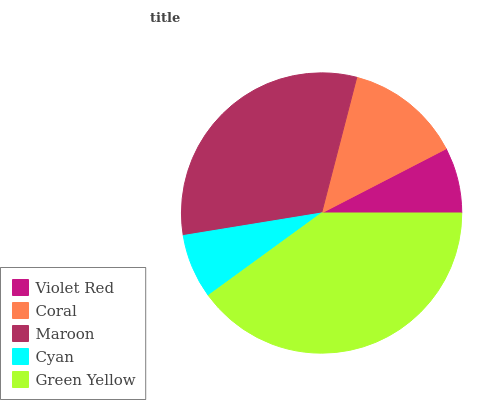Is Cyan the minimum?
Answer yes or no. Yes. Is Green Yellow the maximum?
Answer yes or no. Yes. Is Coral the minimum?
Answer yes or no. No. Is Coral the maximum?
Answer yes or no. No. Is Coral greater than Violet Red?
Answer yes or no. Yes. Is Violet Red less than Coral?
Answer yes or no. Yes. Is Violet Red greater than Coral?
Answer yes or no. No. Is Coral less than Violet Red?
Answer yes or no. No. Is Coral the high median?
Answer yes or no. Yes. Is Coral the low median?
Answer yes or no. Yes. Is Green Yellow the high median?
Answer yes or no. No. Is Maroon the low median?
Answer yes or no. No. 